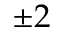Convert formula to latex. <formula><loc_0><loc_0><loc_500><loc_500>\pm 2</formula> 